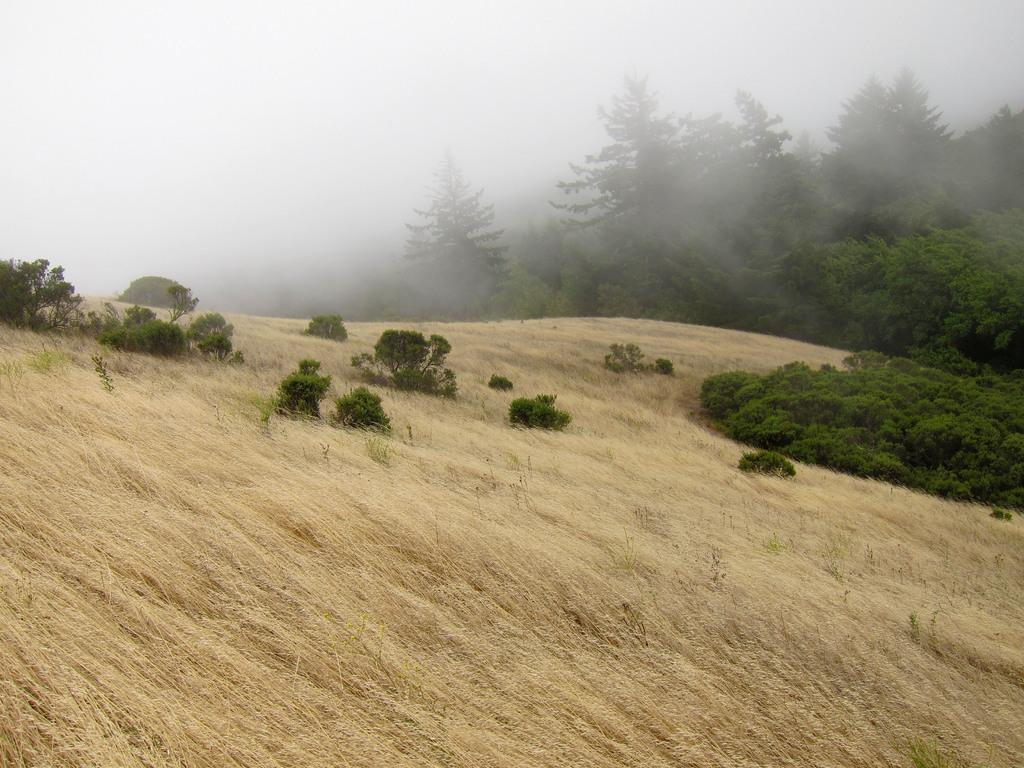What type of vegetation is present in the image? There is dry grass, plants, and trees in the image. Can you describe the weather condition in the image? There is fog visible in the top left corner of the image. How many frogs can be seen hopping through the dry grass in the image? There are no frogs visible in the image; it only features dry grass, plants, and trees. What type of building is located behind the trees in the image? There is no building present in the image; it only features dry grass, plants, trees, and fog. 